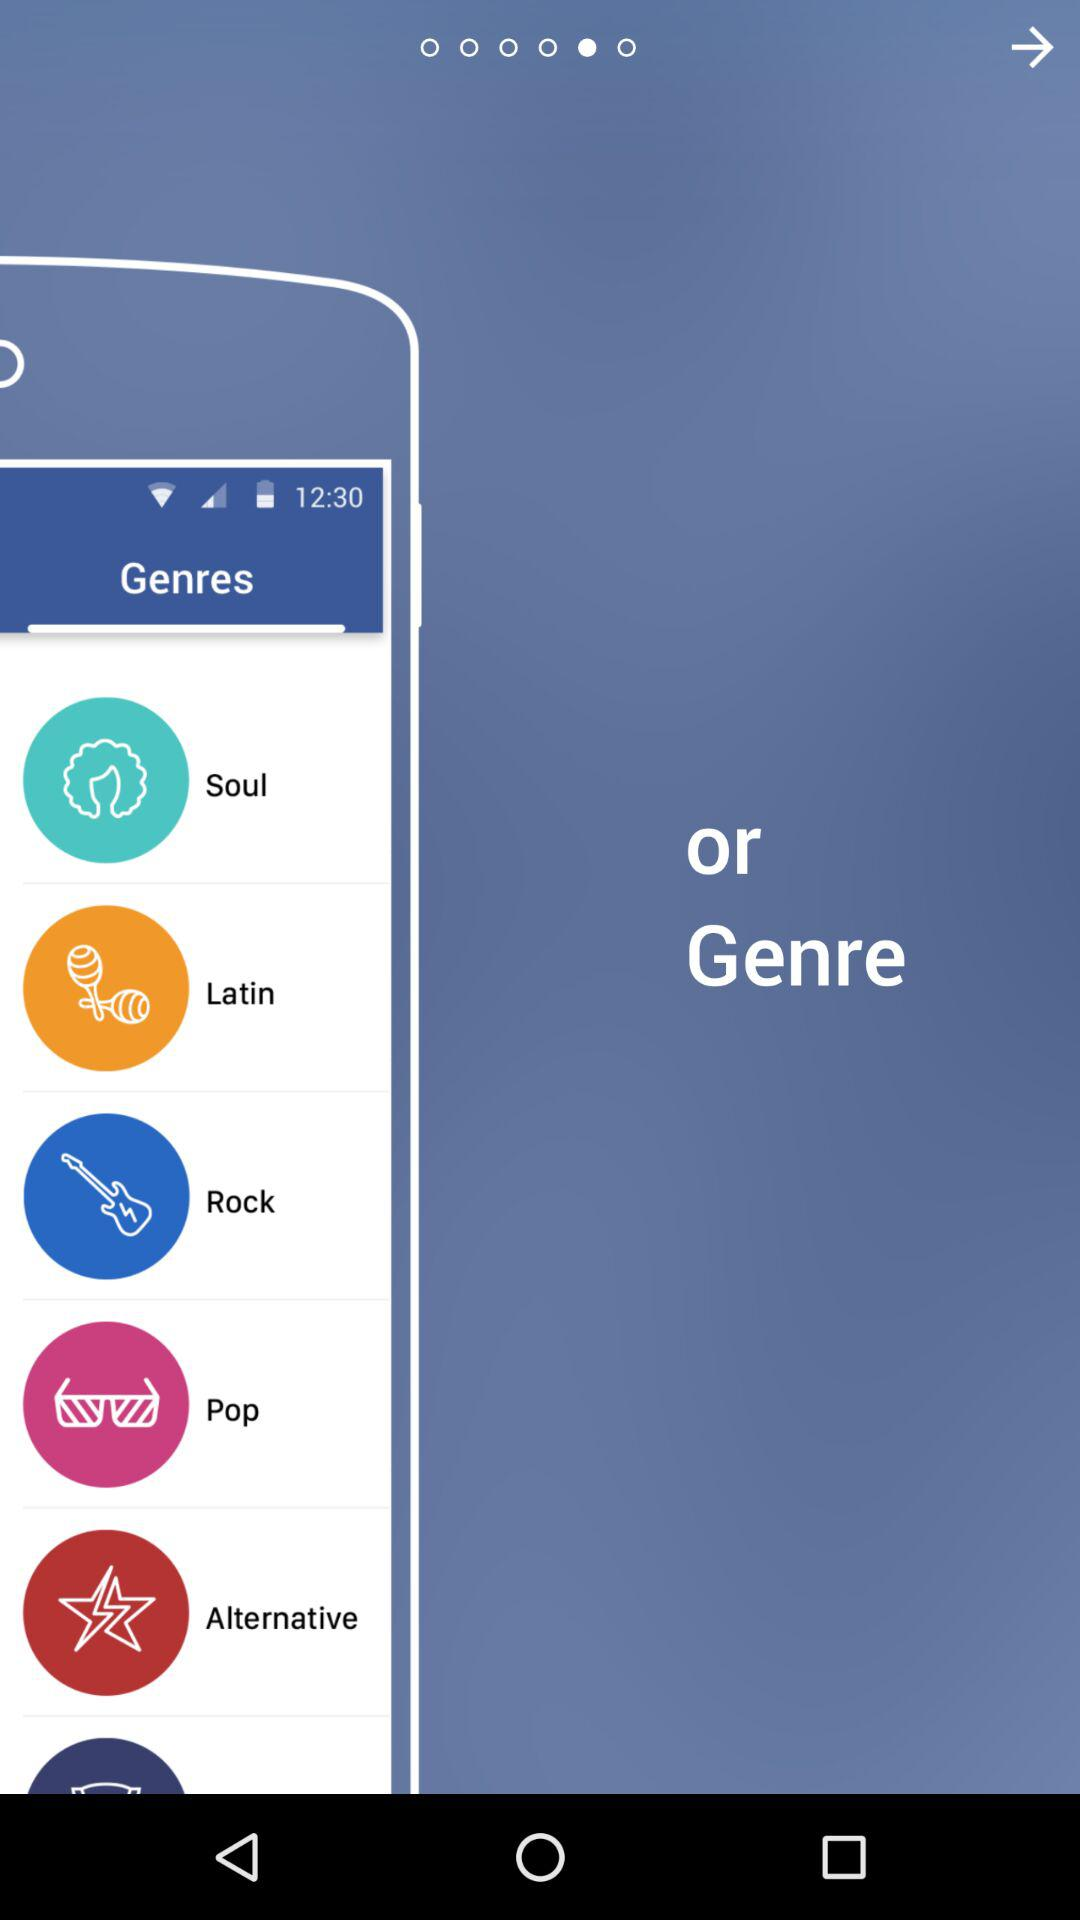How many genres are there in total?
Answer the question using a single word or phrase. 6 